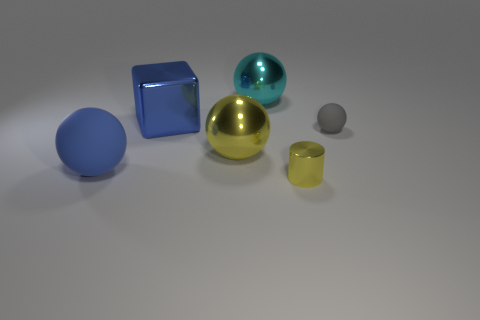Subtract 1 balls. How many balls are left? 3 Subtract all blocks. How many objects are left? 5 Add 1 tiny yellow metallic things. How many objects exist? 7 Subtract all tiny yellow cylinders. Subtract all blue matte spheres. How many objects are left? 4 Add 4 tiny gray rubber objects. How many tiny gray rubber objects are left? 5 Add 5 matte things. How many matte things exist? 7 Subtract 0 yellow cubes. How many objects are left? 6 